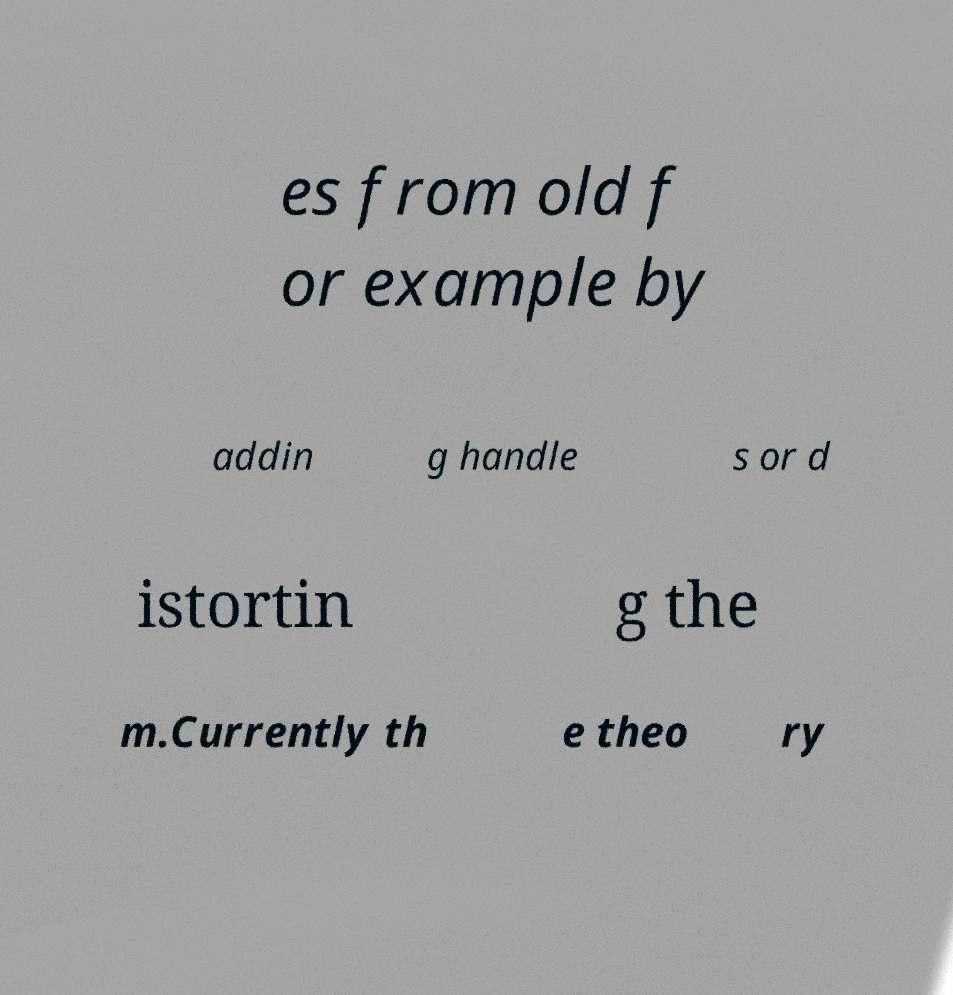For documentation purposes, I need the text within this image transcribed. Could you provide that? es from old f or example by addin g handle s or d istortin g the m.Currently th e theo ry 